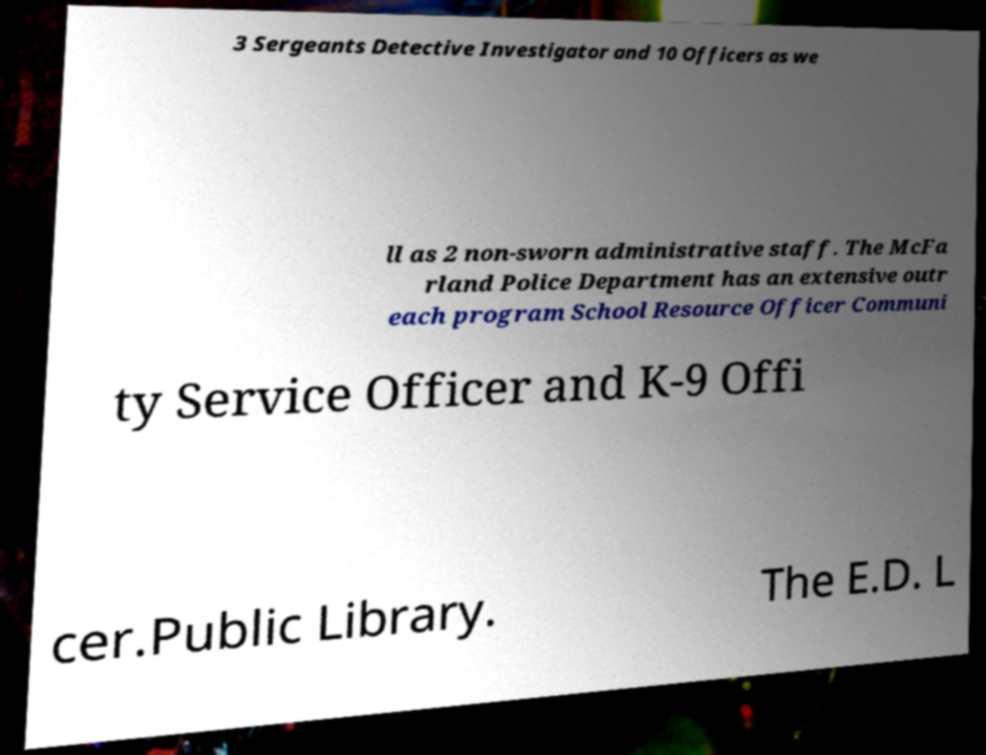Please identify and transcribe the text found in this image. 3 Sergeants Detective Investigator and 10 Officers as we ll as 2 non-sworn administrative staff. The McFa rland Police Department has an extensive outr each program School Resource Officer Communi ty Service Officer and K-9 Offi cer.Public Library. The E.D. L 